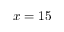<formula> <loc_0><loc_0><loc_500><loc_500>x = 1 5</formula> 